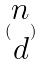<formula> <loc_0><loc_0><loc_500><loc_500>( \begin{matrix} n \\ d \end{matrix} )</formula> 